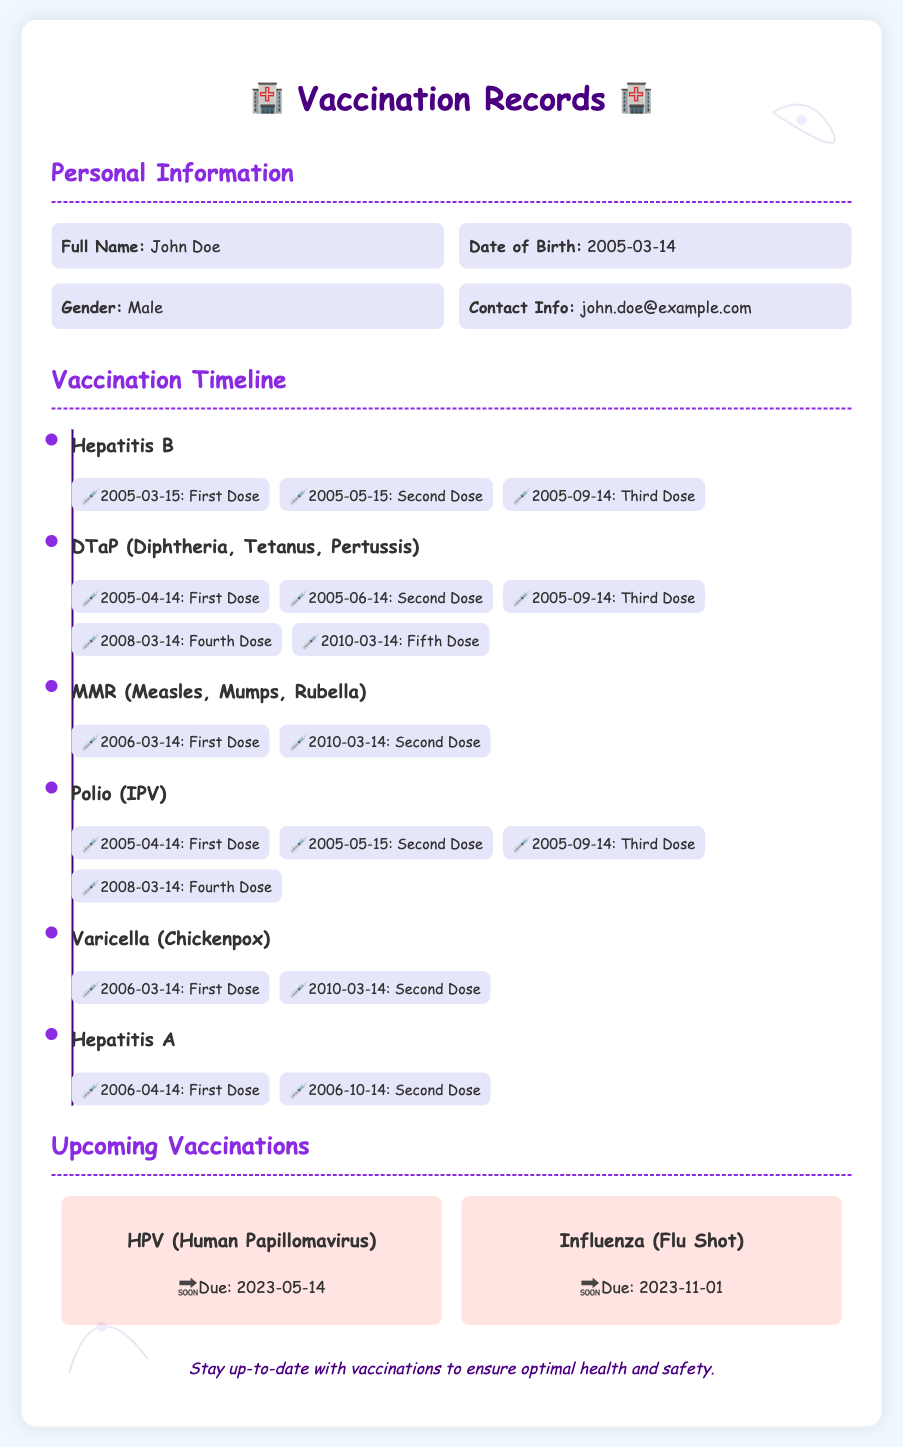What is the full name on the vaccination record? The full name is listed in the personal information section of the document.
Answer: John Doe When was the first dose of Hepatitis B administered? The date of the first dose of Hepatitis B is provided in the vaccination timeline.
Answer: 2005-03-15 How many doses of DTaP vaccine were administered? The number of doses for DTaP can be counted in the timeline for that vaccine.
Answer: Five doses What is the due date for the HPV vaccine? The upcoming vaccinations section lists the due date for the HPV vaccine.
Answer: 2023-05-14 Which vaccine has the second dose listed for the date 2010-03-14? The document provides details about vaccinations along with their respective doses.
Answer: MMR What type of vaccine is due on 2023-11-01? The upcoming vaccinations section indicates which vaccines are due on specific dates.
Answer: Influenza How many total vaccines are listed in the vaccination timeline? The number of vaccine categories can be counted from the timeline section.
Answer: Six vaccines What is the contact information provided in the document? The contact information is included in the personal information part of the document.
Answer: john.doe@example.com 